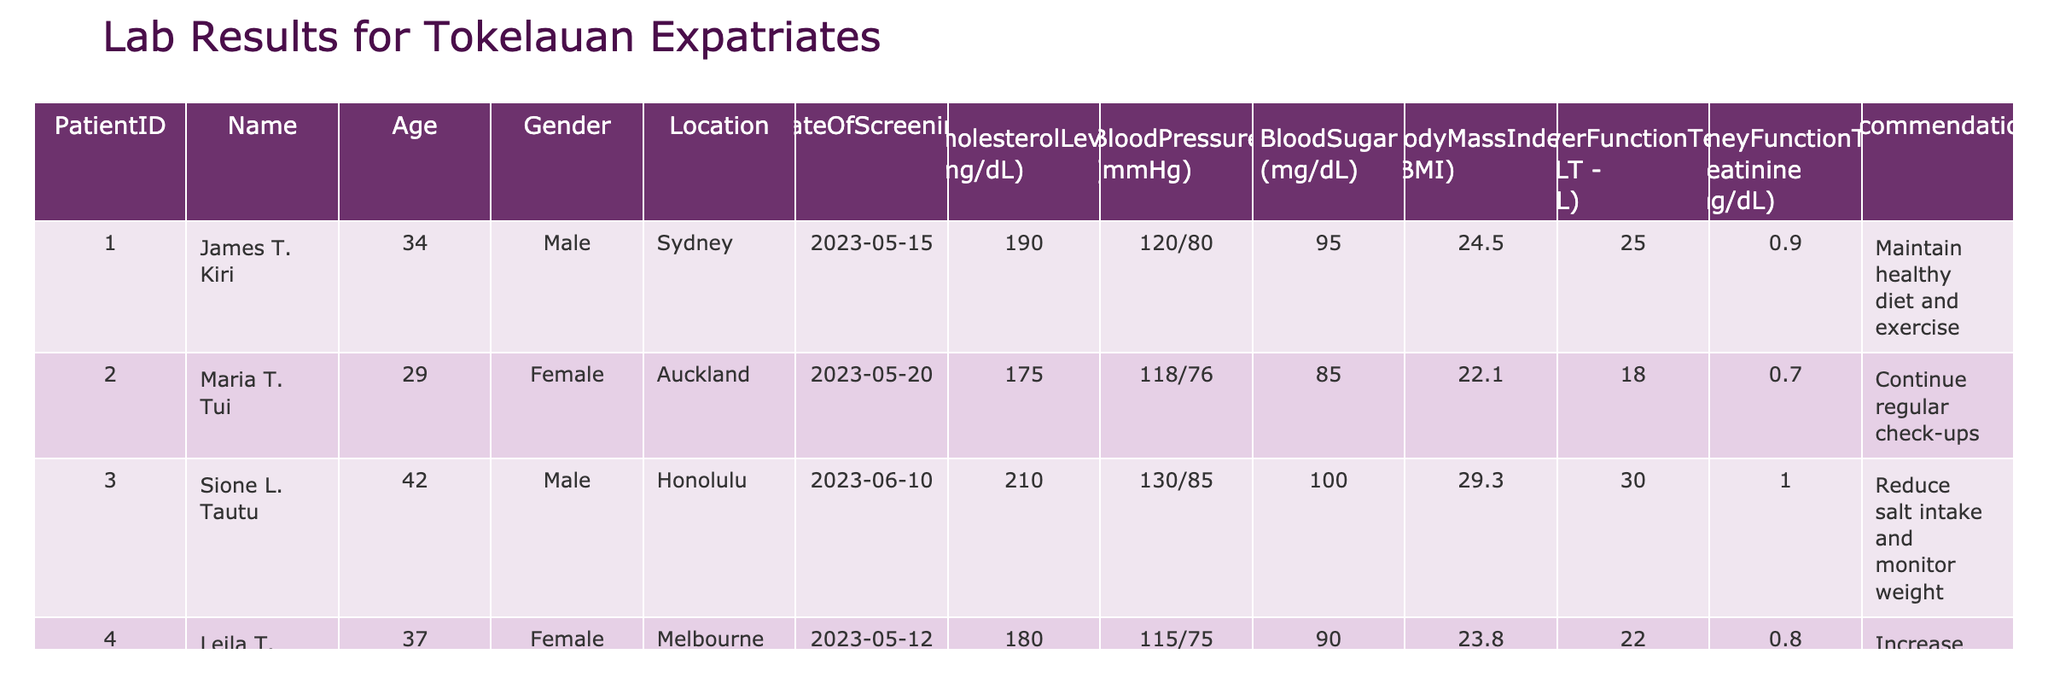What is the cholesterol level of Paul K. Lafaiki? Paul K. Lafaiki's cholesterol level is 240 mg/dL as stated in the table under the Cholesterol Level column for PatientID 005.
Answer: 240 mg/dL How many patients have a blood pressure reading of 120/80 mmHg? There is only one patient, James T. Kiri, with a blood pressure reading of 120/80 mmHg as shown in the Blood Pressure column.
Answer: 1 What is the average age of all patients in the table? The ages of the patients are 34, 29, 42, 37, and 50. Adding these together gives 34 + 29 + 42 + 37 + 50 = 192. Dividing by the number of patients, which is 5, the average age is 192/5 = 38.4.
Answer: 38.4 Is there any female patient whose cholesterol level is above 180 mg/dL? Yes, there is one female patient, Leila T. Tau, with a cholesterol level of 180 mg/dL, which meets the criteria of being above 180 mg/dL stated in the Cholesterol Level column.
Answer: Yes What is the highest recorded Body Mass Index (BMI) among the patients? The BMI values are 24.5, 22.1, 29.3, 23.8, and 32.5. The highest value is 32.5 corresponding to Paul K. Lafaiki, clearly identifiable in the Body Mass Index column.
Answer: 32.5 What recommendations were made for patients with cholesterol levels above 200 mg/dL? Only Sione L. Tautu (cholesterol 210 mg/dL) and Paul K. Lafaiki (cholesterol 240 mg/dL) have cholesterol levels above 200. Their recommendations are "Reduce salt intake and monitor weight" and "Consider lifestyle changes and consult doctor," respectively, as detailed in the Recommendations column.
Answer: Sione: Reduce salt intake and monitor weight; Paul: Consider lifestyle changes and consult doctor How many patients are recommended to maintain or improve their diet and exercise routine? Three patients are recommended to maintain or improve their diet and exercise: James T. Kiri, Paul K. Lafaiki, and Sione L. Tautu as seen in the Recommendations column.
Answer: 3 What is the relationship between age and blood pressure readings of the patients? A review shows that older patients tend to have higher blood pressure readings; for example, Paul K. Lafaiki (age 50) has a blood pressure reading of 140/90 mmHg, while younger patients like Maria T. Tui (age 29) have lower readings at 118/76 mmHg, indicating a potential correlation between age and higher blood pressure.
Answer: Older patients tend to have higher blood pressure readings 